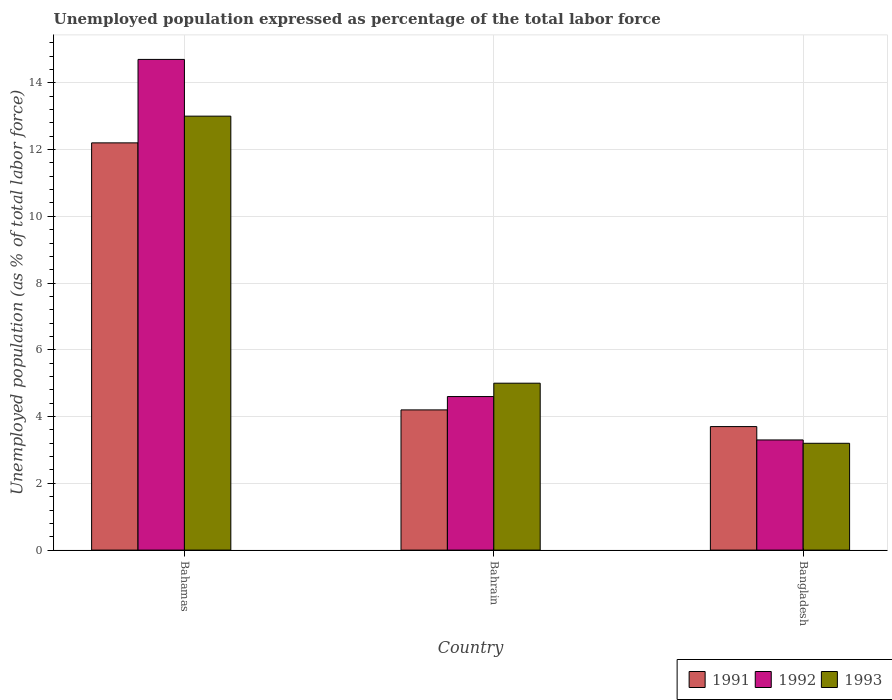Are the number of bars per tick equal to the number of legend labels?
Your response must be concise. Yes. How many bars are there on the 2nd tick from the left?
Keep it short and to the point. 3. How many bars are there on the 2nd tick from the right?
Your response must be concise. 3. What is the label of the 3rd group of bars from the left?
Offer a terse response. Bangladesh. In how many cases, is the number of bars for a given country not equal to the number of legend labels?
Provide a succinct answer. 0. What is the unemployment in in 1992 in Bahrain?
Ensure brevity in your answer.  4.6. Across all countries, what is the maximum unemployment in in 1991?
Give a very brief answer. 12.2. Across all countries, what is the minimum unemployment in in 1993?
Provide a short and direct response. 3.2. In which country was the unemployment in in 1993 maximum?
Provide a succinct answer. Bahamas. In which country was the unemployment in in 1992 minimum?
Offer a terse response. Bangladesh. What is the total unemployment in in 1993 in the graph?
Ensure brevity in your answer.  21.2. What is the difference between the unemployment in in 1992 in Bahrain and that in Bangladesh?
Your answer should be compact. 1.3. What is the difference between the unemployment in in 1993 in Bahamas and the unemployment in in 1991 in Bangladesh?
Offer a very short reply. 9.3. What is the average unemployment in in 1993 per country?
Make the answer very short. 7.07. What is the difference between the unemployment in of/in 1991 and unemployment in of/in 1993 in Bahrain?
Offer a very short reply. -0.8. What is the ratio of the unemployment in in 1993 in Bahrain to that in Bangladesh?
Your answer should be compact. 1.56. Is the unemployment in in 1993 in Bahrain less than that in Bangladesh?
Your answer should be compact. No. Is the difference between the unemployment in in 1991 in Bahrain and Bangladesh greater than the difference between the unemployment in in 1993 in Bahrain and Bangladesh?
Offer a terse response. No. What is the difference between the highest and the second highest unemployment in in 1992?
Provide a succinct answer. -1.3. What is the difference between the highest and the lowest unemployment in in 1993?
Your answer should be very brief. 9.8. What does the 1st bar from the left in Bahamas represents?
Your response must be concise. 1991. What does the 1st bar from the right in Bangladesh represents?
Give a very brief answer. 1993. How many bars are there?
Make the answer very short. 9. How many countries are there in the graph?
Offer a very short reply. 3. What is the difference between two consecutive major ticks on the Y-axis?
Your response must be concise. 2. Are the values on the major ticks of Y-axis written in scientific E-notation?
Keep it short and to the point. No. Does the graph contain any zero values?
Give a very brief answer. No. Does the graph contain grids?
Offer a terse response. Yes. How many legend labels are there?
Your answer should be compact. 3. What is the title of the graph?
Offer a very short reply. Unemployed population expressed as percentage of the total labor force. What is the label or title of the Y-axis?
Offer a terse response. Unemployed population (as % of total labor force). What is the Unemployed population (as % of total labor force) in 1991 in Bahamas?
Your answer should be very brief. 12.2. What is the Unemployed population (as % of total labor force) of 1992 in Bahamas?
Make the answer very short. 14.7. What is the Unemployed population (as % of total labor force) in 1993 in Bahamas?
Your response must be concise. 13. What is the Unemployed population (as % of total labor force) in 1991 in Bahrain?
Offer a terse response. 4.2. What is the Unemployed population (as % of total labor force) of 1992 in Bahrain?
Your answer should be very brief. 4.6. What is the Unemployed population (as % of total labor force) of 1993 in Bahrain?
Your response must be concise. 5. What is the Unemployed population (as % of total labor force) in 1991 in Bangladesh?
Offer a very short reply. 3.7. What is the Unemployed population (as % of total labor force) in 1992 in Bangladesh?
Ensure brevity in your answer.  3.3. What is the Unemployed population (as % of total labor force) in 1993 in Bangladesh?
Your answer should be very brief. 3.2. Across all countries, what is the maximum Unemployed population (as % of total labor force) in 1991?
Ensure brevity in your answer.  12.2. Across all countries, what is the maximum Unemployed population (as % of total labor force) of 1992?
Your answer should be compact. 14.7. Across all countries, what is the maximum Unemployed population (as % of total labor force) of 1993?
Provide a short and direct response. 13. Across all countries, what is the minimum Unemployed population (as % of total labor force) in 1991?
Your response must be concise. 3.7. Across all countries, what is the minimum Unemployed population (as % of total labor force) of 1992?
Provide a succinct answer. 3.3. Across all countries, what is the minimum Unemployed population (as % of total labor force) in 1993?
Keep it short and to the point. 3.2. What is the total Unemployed population (as % of total labor force) in 1991 in the graph?
Your answer should be very brief. 20.1. What is the total Unemployed population (as % of total labor force) of 1992 in the graph?
Offer a very short reply. 22.6. What is the total Unemployed population (as % of total labor force) of 1993 in the graph?
Make the answer very short. 21.2. What is the difference between the Unemployed population (as % of total labor force) in 1991 in Bahamas and that in Bahrain?
Ensure brevity in your answer.  8. What is the difference between the Unemployed population (as % of total labor force) in 1991 in Bahamas and that in Bangladesh?
Offer a terse response. 8.5. What is the difference between the Unemployed population (as % of total labor force) of 1992 in Bahrain and that in Bangladesh?
Provide a succinct answer. 1.3. What is the difference between the Unemployed population (as % of total labor force) in 1993 in Bahrain and that in Bangladesh?
Your answer should be very brief. 1.8. What is the difference between the Unemployed population (as % of total labor force) of 1991 in Bahamas and the Unemployed population (as % of total labor force) of 1993 in Bahrain?
Offer a terse response. 7.2. What is the difference between the Unemployed population (as % of total labor force) of 1992 in Bahamas and the Unemployed population (as % of total labor force) of 1993 in Bahrain?
Provide a succinct answer. 9.7. What is the difference between the Unemployed population (as % of total labor force) in 1992 in Bahamas and the Unemployed population (as % of total labor force) in 1993 in Bangladesh?
Your response must be concise. 11.5. What is the average Unemployed population (as % of total labor force) of 1991 per country?
Offer a terse response. 6.7. What is the average Unemployed population (as % of total labor force) of 1992 per country?
Ensure brevity in your answer.  7.53. What is the average Unemployed population (as % of total labor force) of 1993 per country?
Your answer should be compact. 7.07. What is the difference between the Unemployed population (as % of total labor force) of 1991 and Unemployed population (as % of total labor force) of 1992 in Bahamas?
Make the answer very short. -2.5. What is the difference between the Unemployed population (as % of total labor force) of 1991 and Unemployed population (as % of total labor force) of 1993 in Bahamas?
Give a very brief answer. -0.8. What is the difference between the Unemployed population (as % of total labor force) in 1991 and Unemployed population (as % of total labor force) in 1992 in Bahrain?
Ensure brevity in your answer.  -0.4. What is the difference between the Unemployed population (as % of total labor force) in 1991 and Unemployed population (as % of total labor force) in 1993 in Bahrain?
Give a very brief answer. -0.8. What is the difference between the Unemployed population (as % of total labor force) of 1991 and Unemployed population (as % of total labor force) of 1992 in Bangladesh?
Provide a short and direct response. 0.4. What is the difference between the Unemployed population (as % of total labor force) of 1991 and Unemployed population (as % of total labor force) of 1993 in Bangladesh?
Provide a short and direct response. 0.5. What is the difference between the Unemployed population (as % of total labor force) in 1992 and Unemployed population (as % of total labor force) in 1993 in Bangladesh?
Ensure brevity in your answer.  0.1. What is the ratio of the Unemployed population (as % of total labor force) in 1991 in Bahamas to that in Bahrain?
Your answer should be very brief. 2.9. What is the ratio of the Unemployed population (as % of total labor force) in 1992 in Bahamas to that in Bahrain?
Provide a short and direct response. 3.2. What is the ratio of the Unemployed population (as % of total labor force) in 1991 in Bahamas to that in Bangladesh?
Keep it short and to the point. 3.3. What is the ratio of the Unemployed population (as % of total labor force) of 1992 in Bahamas to that in Bangladesh?
Make the answer very short. 4.45. What is the ratio of the Unemployed population (as % of total labor force) in 1993 in Bahamas to that in Bangladesh?
Ensure brevity in your answer.  4.06. What is the ratio of the Unemployed population (as % of total labor force) in 1991 in Bahrain to that in Bangladesh?
Give a very brief answer. 1.14. What is the ratio of the Unemployed population (as % of total labor force) in 1992 in Bahrain to that in Bangladesh?
Your answer should be compact. 1.39. What is the ratio of the Unemployed population (as % of total labor force) of 1993 in Bahrain to that in Bangladesh?
Ensure brevity in your answer.  1.56. What is the difference between the highest and the second highest Unemployed population (as % of total labor force) in 1992?
Keep it short and to the point. 10.1. What is the difference between the highest and the second highest Unemployed population (as % of total labor force) of 1993?
Provide a short and direct response. 8. What is the difference between the highest and the lowest Unemployed population (as % of total labor force) of 1991?
Offer a terse response. 8.5. What is the difference between the highest and the lowest Unemployed population (as % of total labor force) of 1992?
Provide a short and direct response. 11.4. 